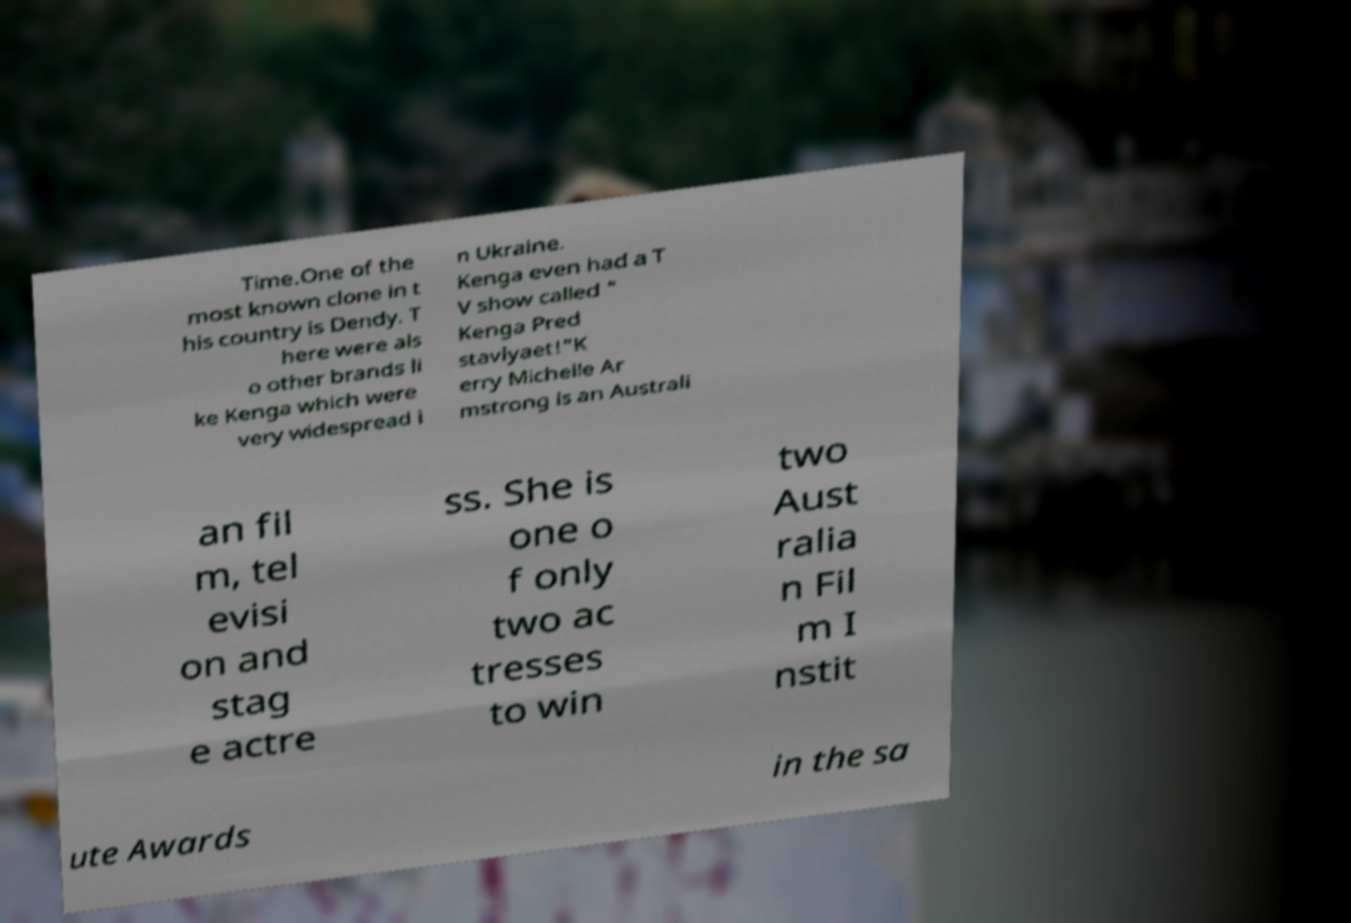Please identify and transcribe the text found in this image. Time.One of the most known clone in t his country is Dendy. T here were als o other brands li ke Kenga which were very widespread i n Ukraine. Kenga even had a T V show called " Kenga Pred stavlyaet!"K erry Michelle Ar mstrong is an Australi an fil m, tel evisi on and stag e actre ss. She is one o f only two ac tresses to win two Aust ralia n Fil m I nstit ute Awards in the sa 